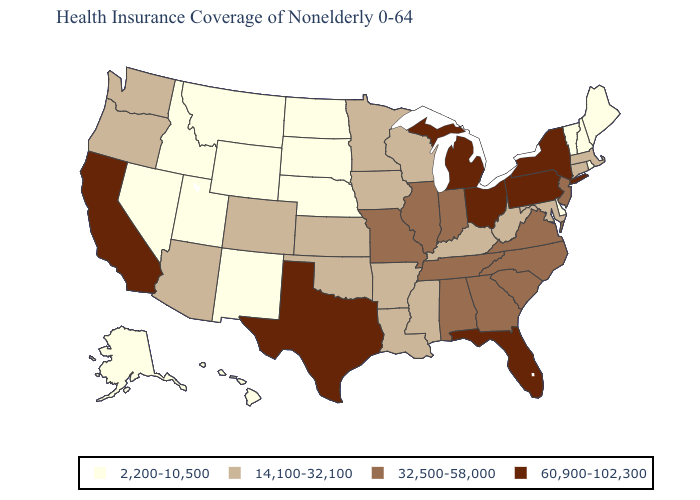Does Arizona have the lowest value in the USA?
Short answer required. No. Name the states that have a value in the range 14,100-32,100?
Be succinct. Arizona, Arkansas, Colorado, Connecticut, Iowa, Kansas, Kentucky, Louisiana, Maryland, Massachusetts, Minnesota, Mississippi, Oklahoma, Oregon, Washington, West Virginia, Wisconsin. Which states have the lowest value in the USA?
Answer briefly. Alaska, Delaware, Hawaii, Idaho, Maine, Montana, Nebraska, Nevada, New Hampshire, New Mexico, North Dakota, Rhode Island, South Dakota, Utah, Vermont, Wyoming. What is the lowest value in the Northeast?
Quick response, please. 2,200-10,500. Does the first symbol in the legend represent the smallest category?
Short answer required. Yes. Name the states that have a value in the range 14,100-32,100?
Concise answer only. Arizona, Arkansas, Colorado, Connecticut, Iowa, Kansas, Kentucky, Louisiana, Maryland, Massachusetts, Minnesota, Mississippi, Oklahoma, Oregon, Washington, West Virginia, Wisconsin. What is the lowest value in the USA?
Write a very short answer. 2,200-10,500. Name the states that have a value in the range 14,100-32,100?
Concise answer only. Arizona, Arkansas, Colorado, Connecticut, Iowa, Kansas, Kentucky, Louisiana, Maryland, Massachusetts, Minnesota, Mississippi, Oklahoma, Oregon, Washington, West Virginia, Wisconsin. Name the states that have a value in the range 14,100-32,100?
Write a very short answer. Arizona, Arkansas, Colorado, Connecticut, Iowa, Kansas, Kentucky, Louisiana, Maryland, Massachusetts, Minnesota, Mississippi, Oklahoma, Oregon, Washington, West Virginia, Wisconsin. What is the highest value in states that border Maine?
Concise answer only. 2,200-10,500. Does the first symbol in the legend represent the smallest category?
Short answer required. Yes. What is the lowest value in the MidWest?
Keep it brief. 2,200-10,500. Does the first symbol in the legend represent the smallest category?
Short answer required. Yes. What is the value of Oklahoma?
Quick response, please. 14,100-32,100. Is the legend a continuous bar?
Be succinct. No. 